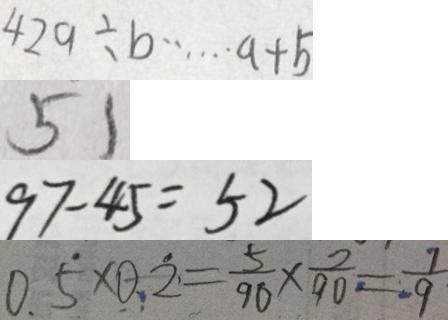<formula> <loc_0><loc_0><loc_500><loc_500>4 2 9 \div b \cdots a + b 
 5 1 
 9 7 - 4 5 = 5 2 
 0 . \dot { 5 } \times 0 . \dot { 2 } = \frac { 5 } { 9 0 } \times \frac { 2 } { 9 0 } = \frac { 1 } { 9 }</formula> 